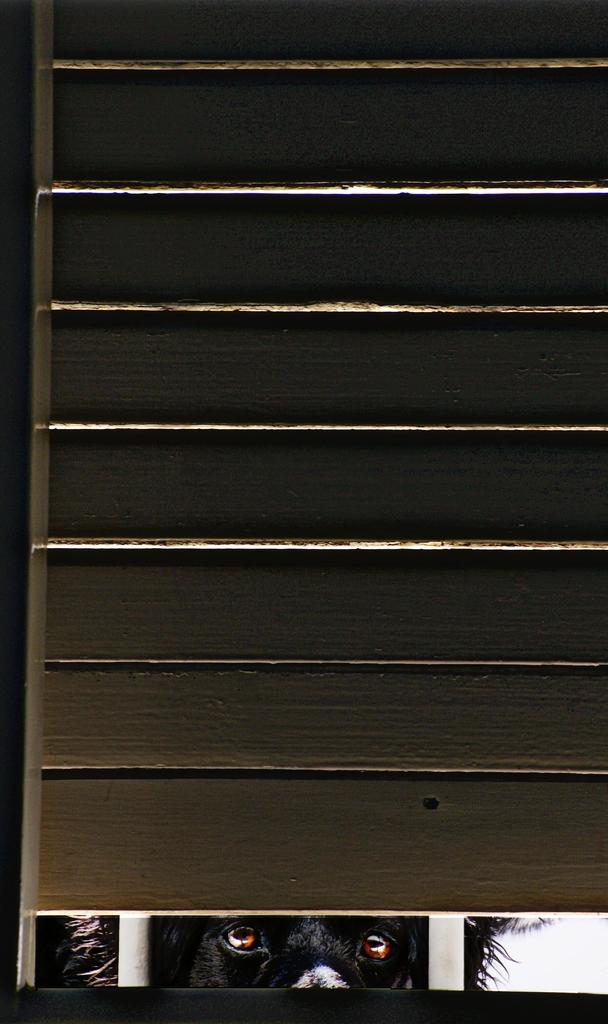What type of animal is in the image? There is a black dog in the image. What are the two white objects in the image? There are two white poles in the image. Can you describe the object that resembles a door? Yes, there is an object that looks like a door in the image. What type of force is being exerted on the dog during the meeting in the bedroom? There is no meeting or bedroom present in the image, and therefore no force can be observed being exerted on the dog. 